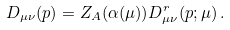<formula> <loc_0><loc_0><loc_500><loc_500>D _ { \mu \nu } ( p ) = Z _ { A } ( \alpha ( \mu ) ) D ^ { r } _ { \mu \nu } ( p ; \mu ) \, .</formula> 